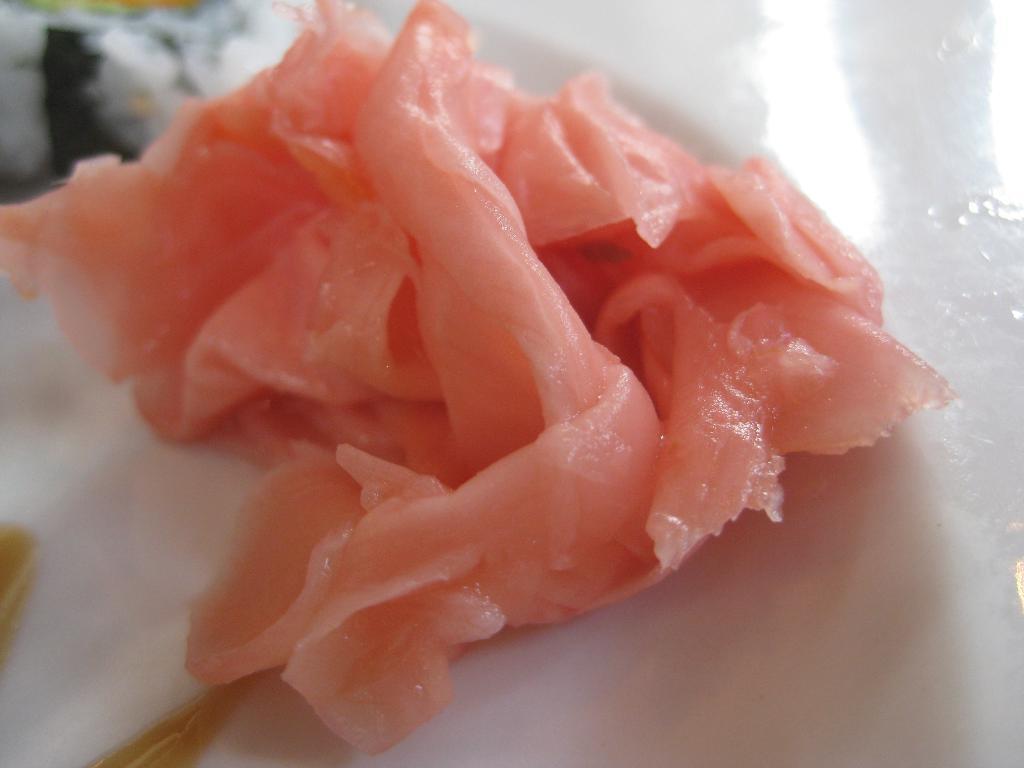Describe this image in one or two sentences. In this image we can see the meat on the white surface. 